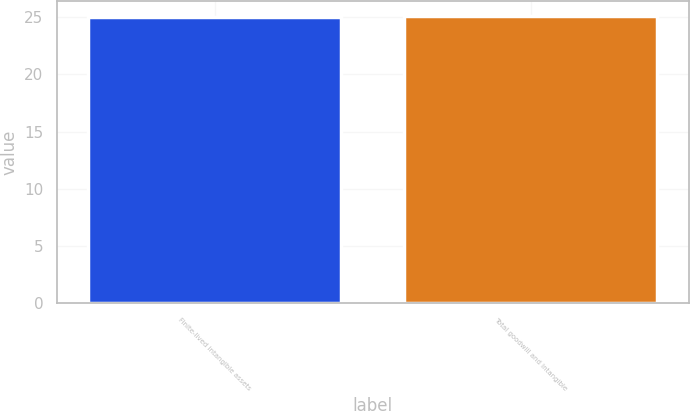<chart> <loc_0><loc_0><loc_500><loc_500><bar_chart><fcel>Finite-lived intangible assets<fcel>Total goodwill and intangible<nl><fcel>25<fcel>25.1<nl></chart> 